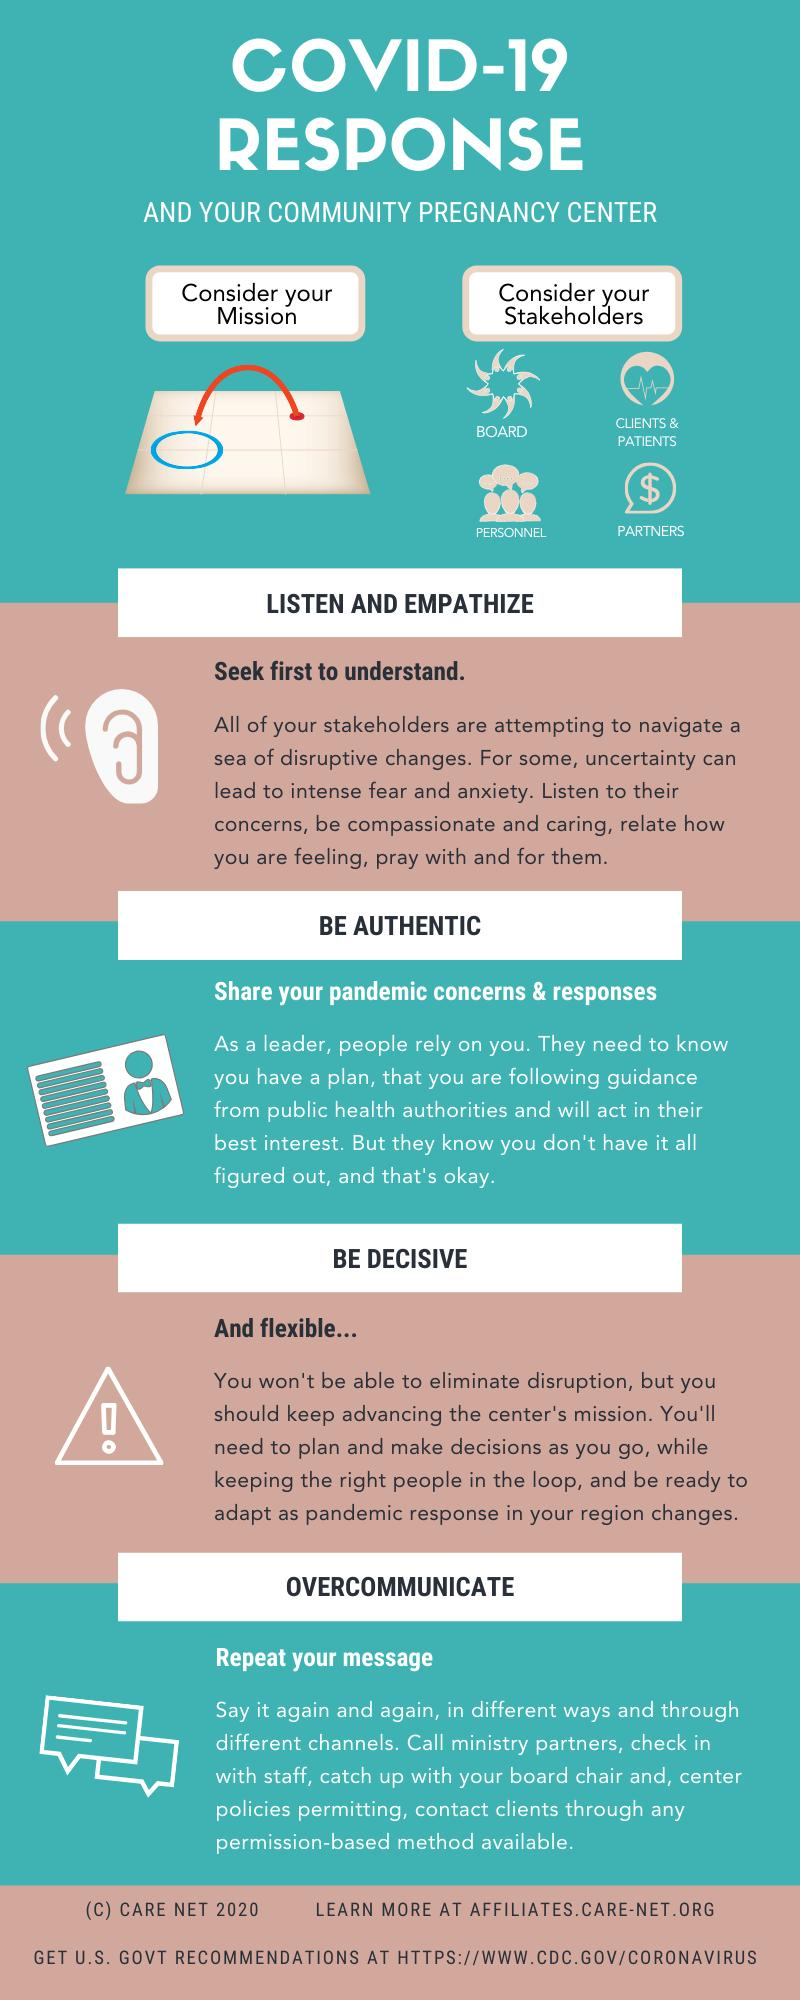Mention a couple of crucial points in this snapshot. The infographic contains four stakeholders that are referenced. 